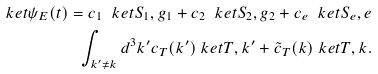Convert formula to latex. <formula><loc_0><loc_0><loc_500><loc_500>\ k e t { \psi _ { E } ( t ) } = c _ { 1 } \ k e t { S _ { 1 } , g _ { 1 } } + c _ { 2 } \ k e t { S _ { 2 } , g _ { 2 } } + c _ { e } \ k e t { S _ { e } , e } \\ \int _ { k ^ { \prime } \neq k } d ^ { 3 } k ^ { \prime } c _ { T } ( k ^ { \prime } ) \ k e t { T , k ^ { \prime } } + \tilde { c } _ { T } ( k ) \ k e t { T , k } .</formula> 